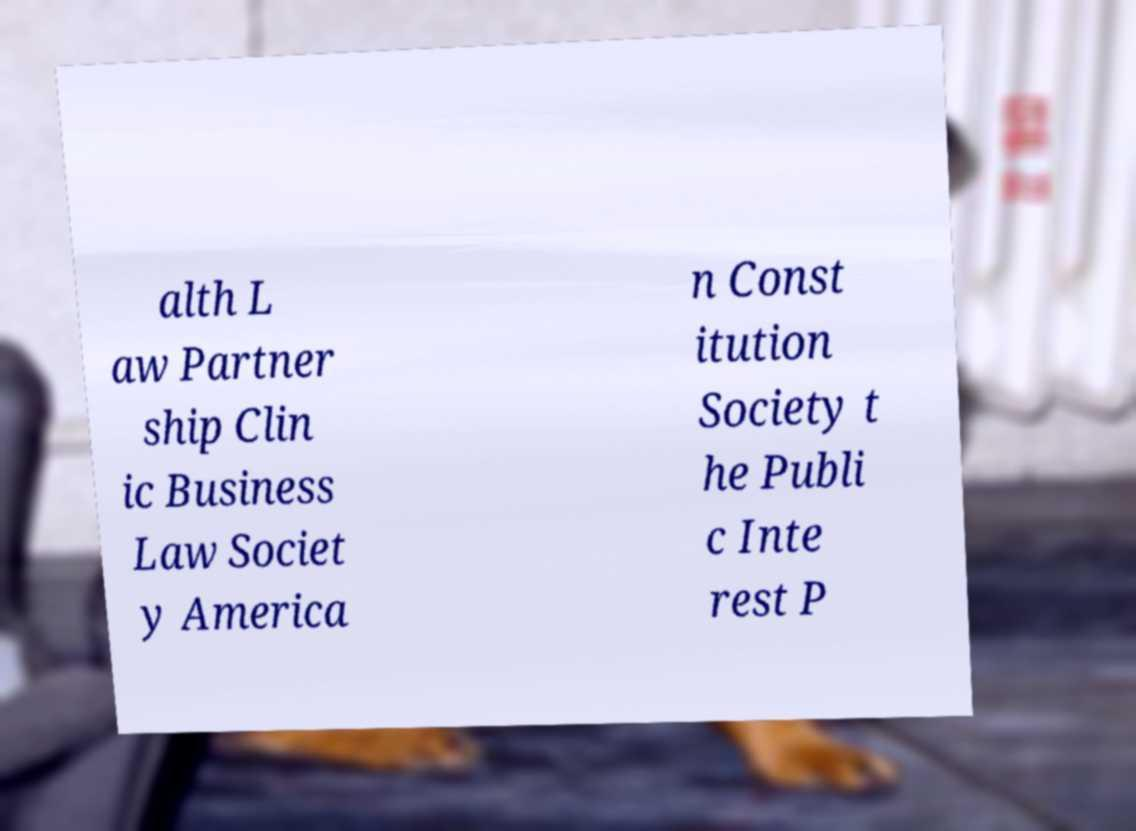Can you read and provide the text displayed in the image?This photo seems to have some interesting text. Can you extract and type it out for me? alth L aw Partner ship Clin ic Business Law Societ y America n Const itution Society t he Publi c Inte rest P 